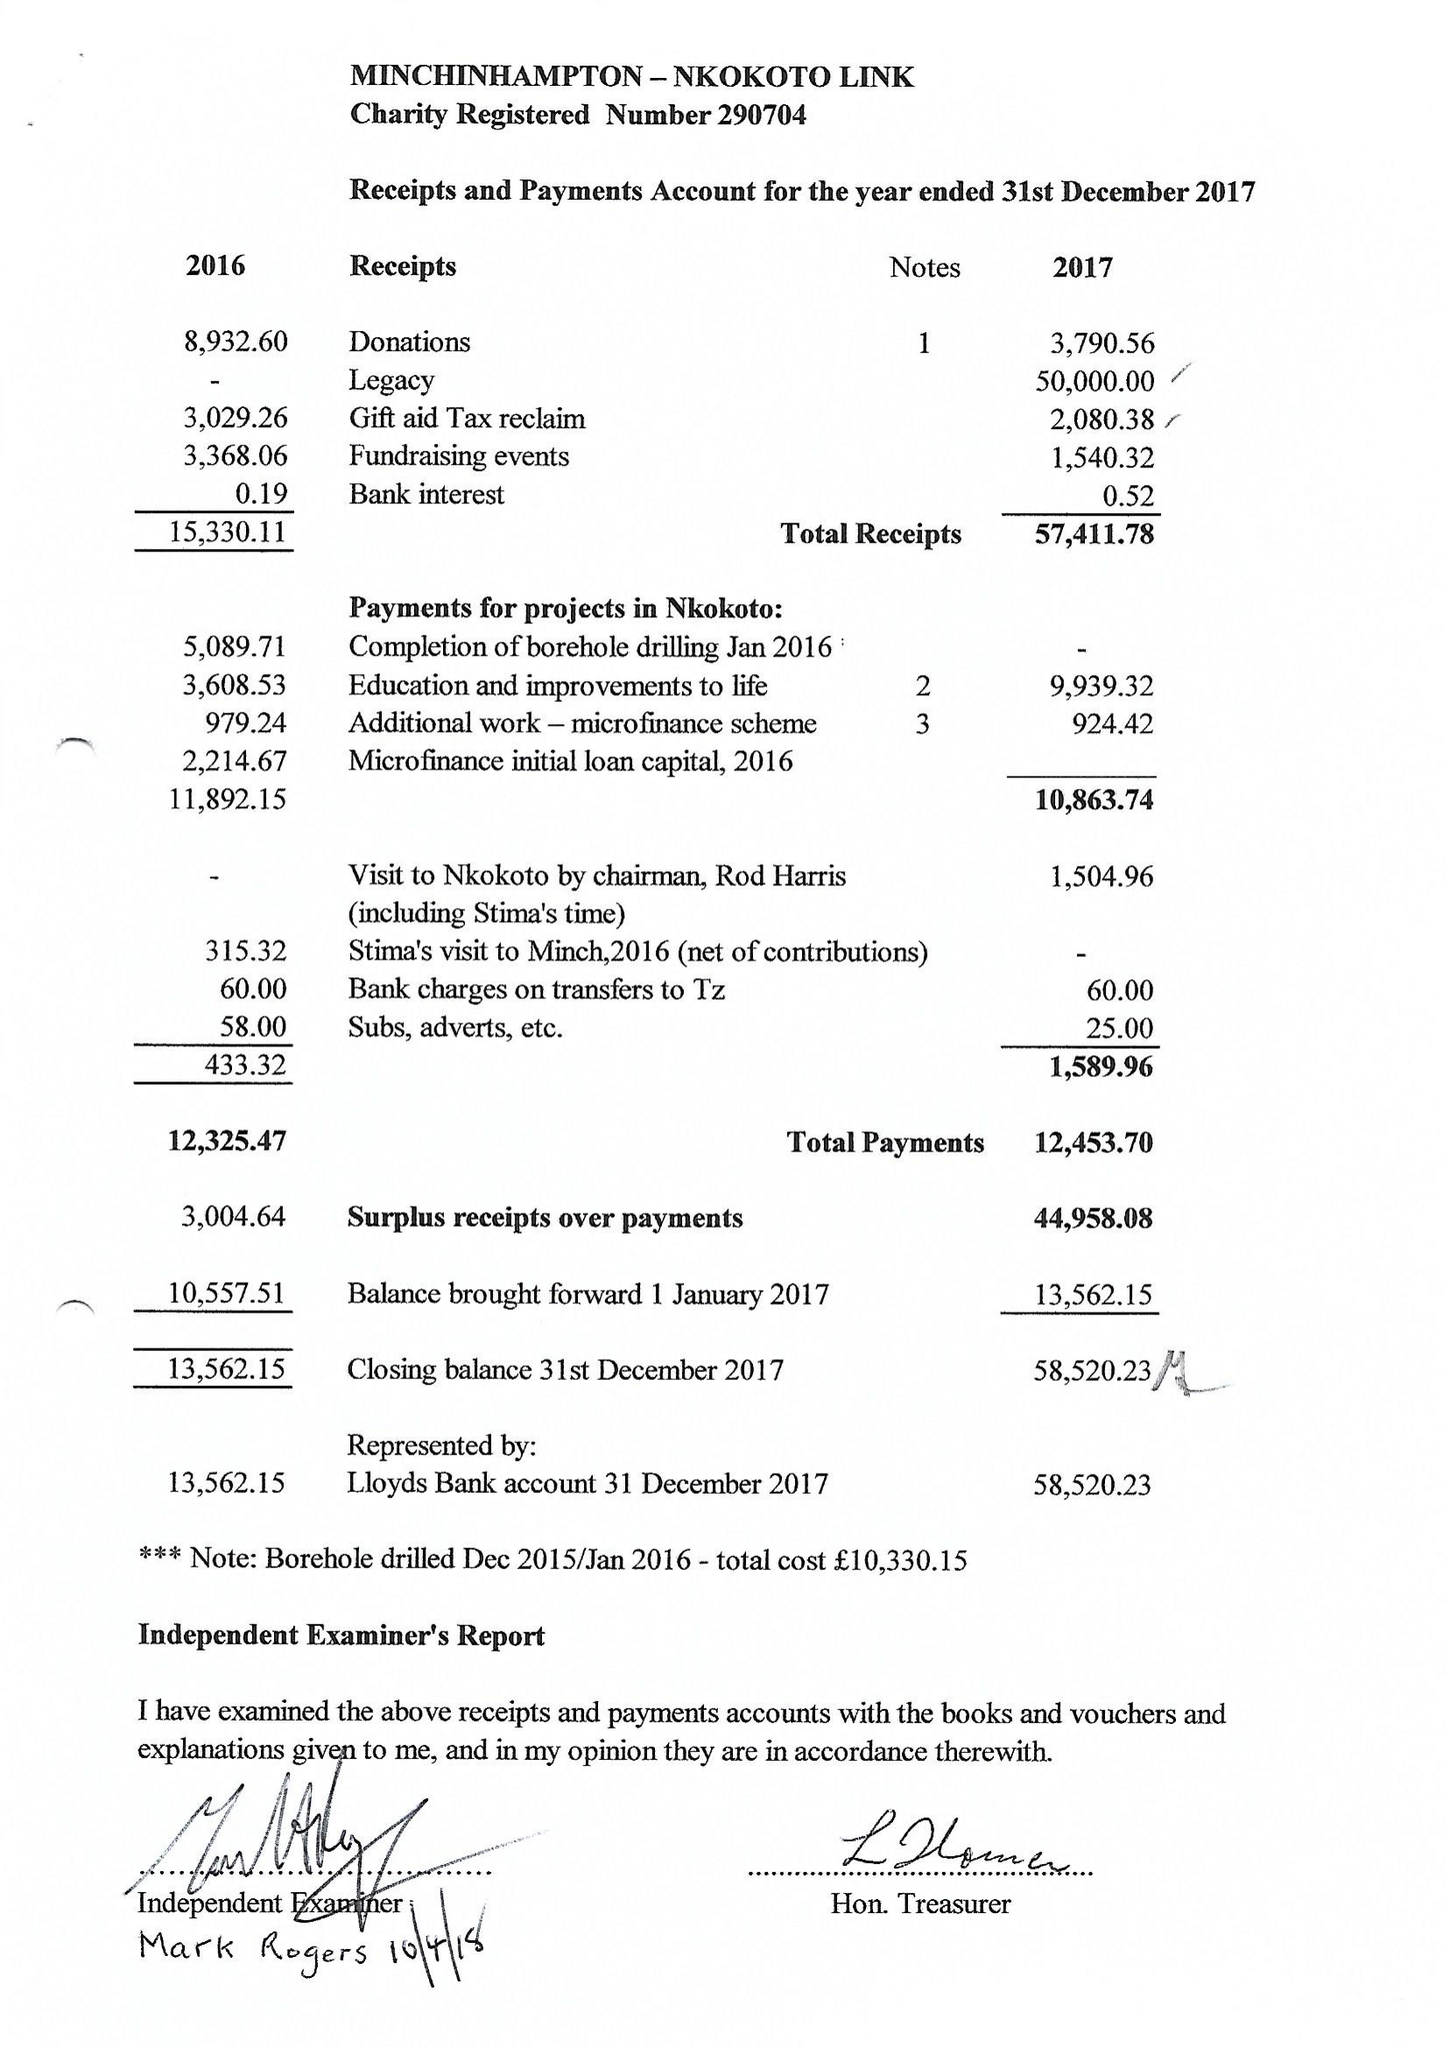What is the value for the income_annually_in_british_pounds?
Answer the question using a single word or phrase. 57412.00 